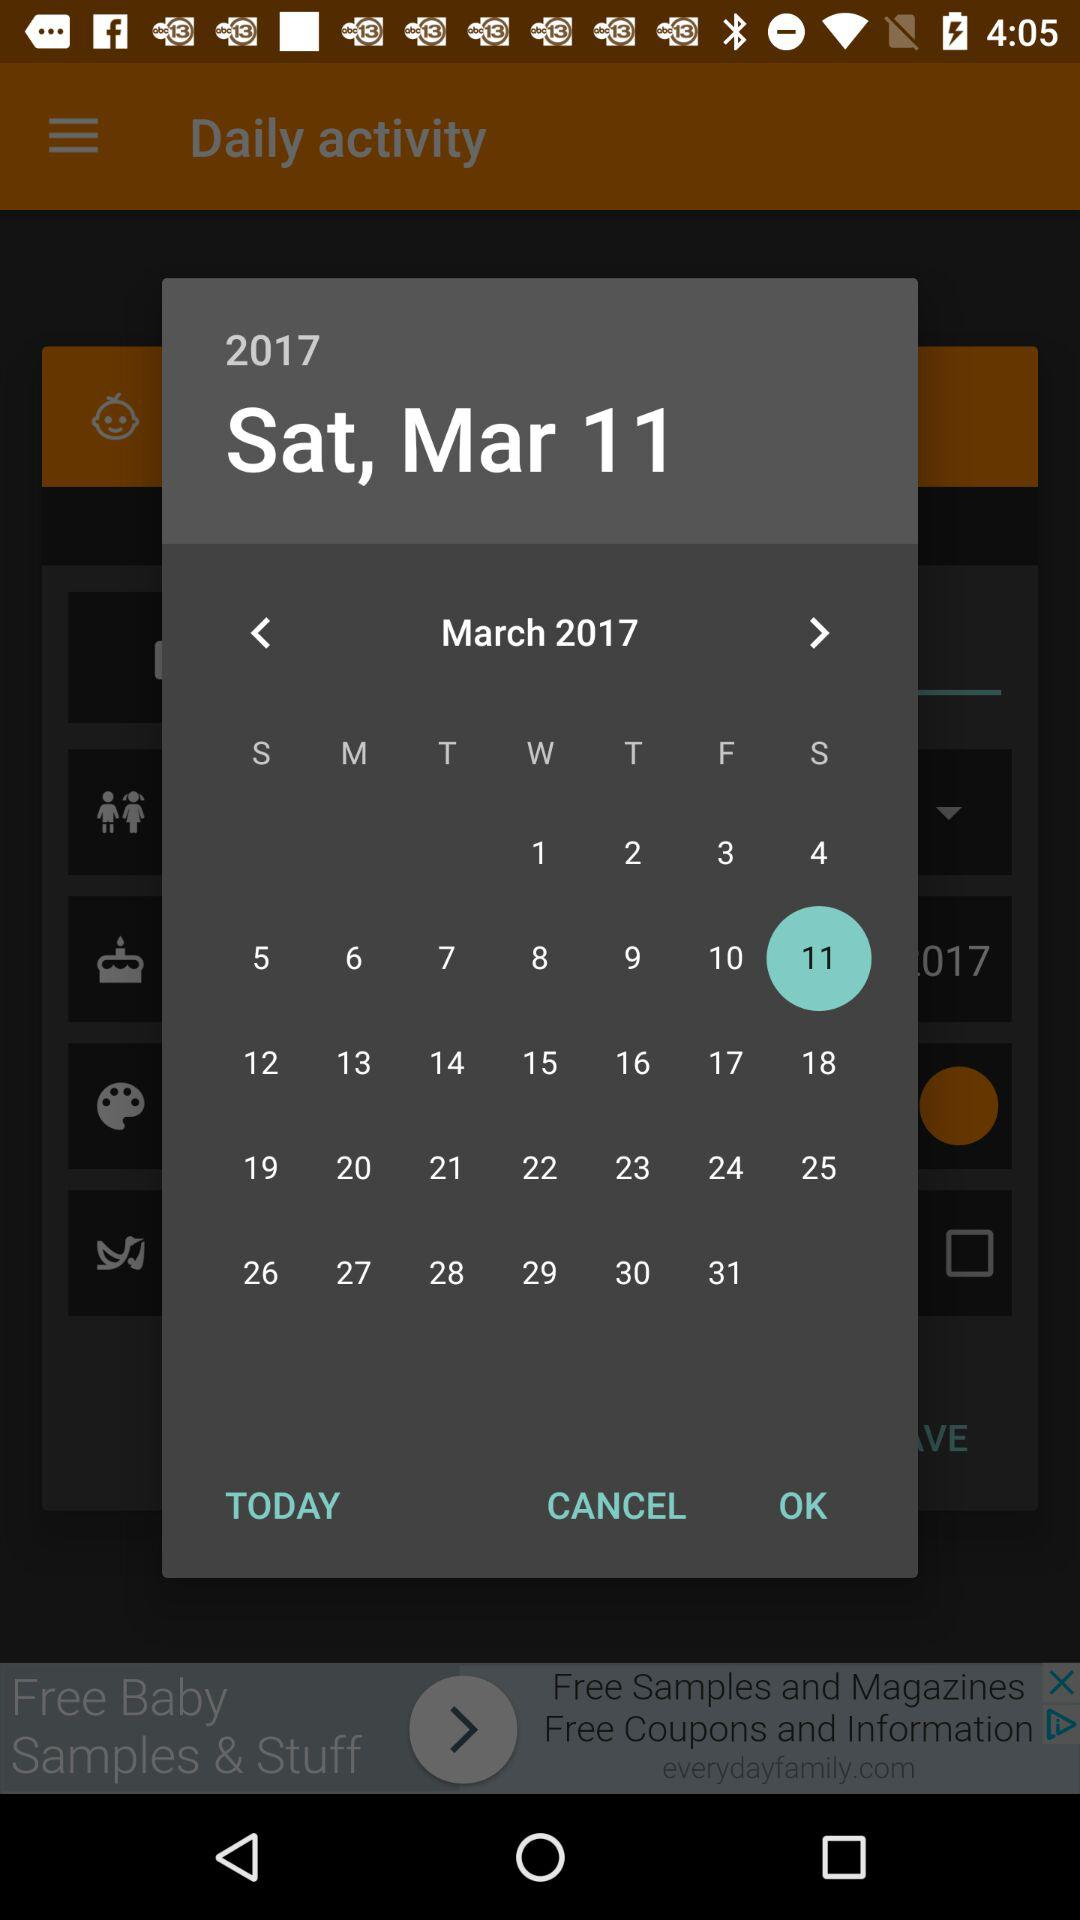What is the day on March 11, 2017? The day is Saturday. 